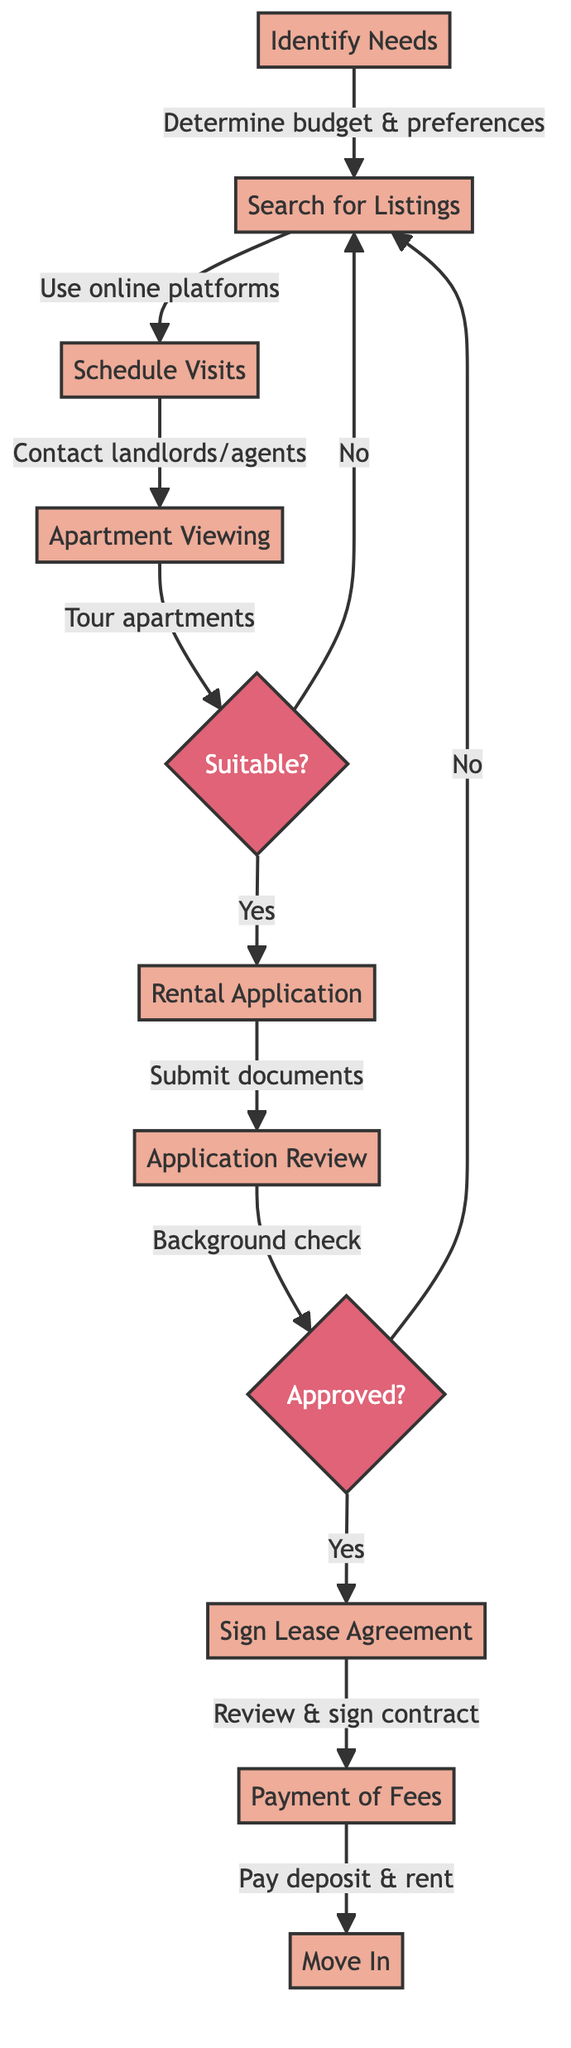What is the first step in renting an apartment? The diagram indicates that the first step is "Identify Needs," where one determines the budget, preferred location, and apartment features.
Answer: Identify Needs How many main steps are there in the apartment renting process? By counting the main steps represented in the flowchart, we see a total of 8 steps.
Answer: 8 What do you do after the apartment viewing? After the apartment viewing, the next step is the "Rental Application."
Answer: Rental Application What happens if the application is not approved? If the application is not approved, according to the diagram, the process returns to "Search for Listings."
Answer: Search for Listings What must be submitted during the rental application? The rental application requires the submission of documents like ID, proof of income, and references.
Answer: ID, proof of income, references What decision point follows the Application Review? The decision point following the Application Review is "Approved?" which determines the next steps based on the outcome.
Answer: Approved? Describe the action taken after signing the lease agreement. After signing the lease agreement, the subsequent action is the "Payment of Fees," where the deposit and rent are paid.
Answer: Payment of Fees What must you do before moving into the apartment? Before moving in, one must coordinate with the landlord for the key handover.
Answer: Coordinate with the landlord for key handover What is the outcome if an apartment is suitable during the viewing? If the apartment is suitable during the viewing, the next step is to proceed with the "Rental Application."
Answer: Rental Application 